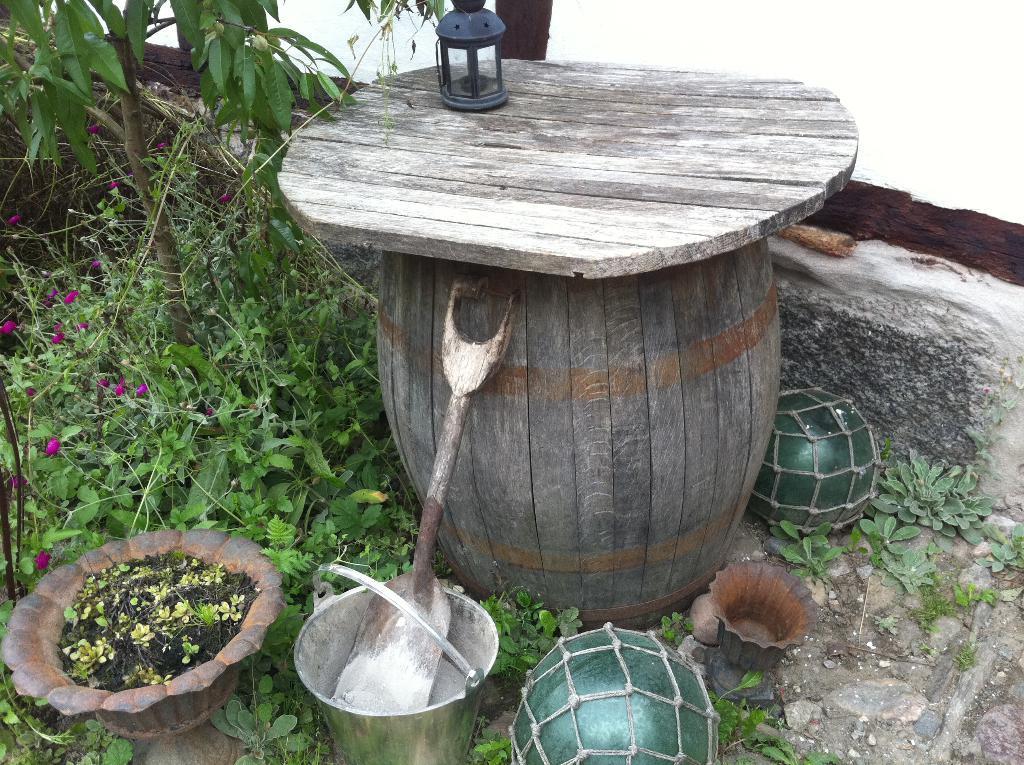Could you give a brief overview of what you see in this image? In this image I can see a wooden pot. I can also see few plants in green color. 